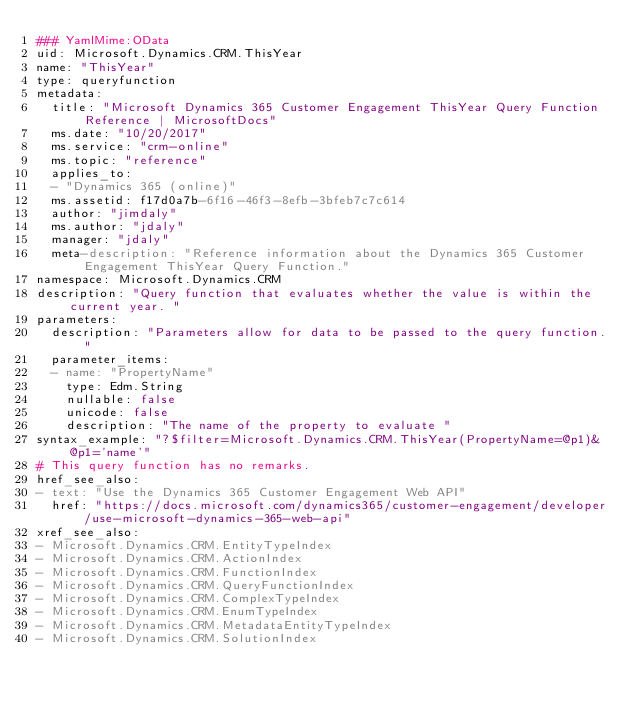Convert code to text. <code><loc_0><loc_0><loc_500><loc_500><_YAML_>### YamlMime:OData
uid: Microsoft.Dynamics.CRM.ThisYear
name: "ThisYear"
type: queryfunction
metadata: 
  title: "Microsoft Dynamics 365 Customer Engagement ThisYear Query Function Reference | MicrosoftDocs"
  ms.date: "10/20/2017"
  ms.service: "crm-online"
  ms.topic: "reference"
  applies_to: 
  - "Dynamics 365 (online)"
  ms.assetid: f17d0a7b-6f16-46f3-8efb-3bfeb7c7c614
  author: "jimdaly"
  ms.author: "jdaly"
  manager: "jdaly"
  meta-description: "Reference information about the Dynamics 365 Customer Engagement ThisYear Query Function."
namespace: Microsoft.Dynamics.CRM
description: "Query function that evaluates whether the value is within the current year. "
parameters:
  description: "Parameters allow for data to be passed to the query function."
  parameter_items:
  - name: "PropertyName"
    type: Edm.String
    nullable: false
    unicode: false
    description: "The name of the property to evaluate "
syntax_example: "?$filter=Microsoft.Dynamics.CRM.ThisYear(PropertyName=@p1)&@p1='name'"
# This query function has no remarks.
href_see_also:
- text: "Use the Dynamics 365 Customer Engagement Web API"
  href: "https://docs.microsoft.com/dynamics365/customer-engagement/developer/use-microsoft-dynamics-365-web-api"
xref_see_also:
- Microsoft.Dynamics.CRM.EntityTypeIndex
- Microsoft.Dynamics.CRM.ActionIndex
- Microsoft.Dynamics.CRM.FunctionIndex
- Microsoft.Dynamics.CRM.QueryFunctionIndex
- Microsoft.Dynamics.CRM.ComplexTypeIndex
- Microsoft.Dynamics.CRM.EnumTypeIndex
- Microsoft.Dynamics.CRM.MetadataEntityTypeIndex
- Microsoft.Dynamics.CRM.SolutionIndex</code> 